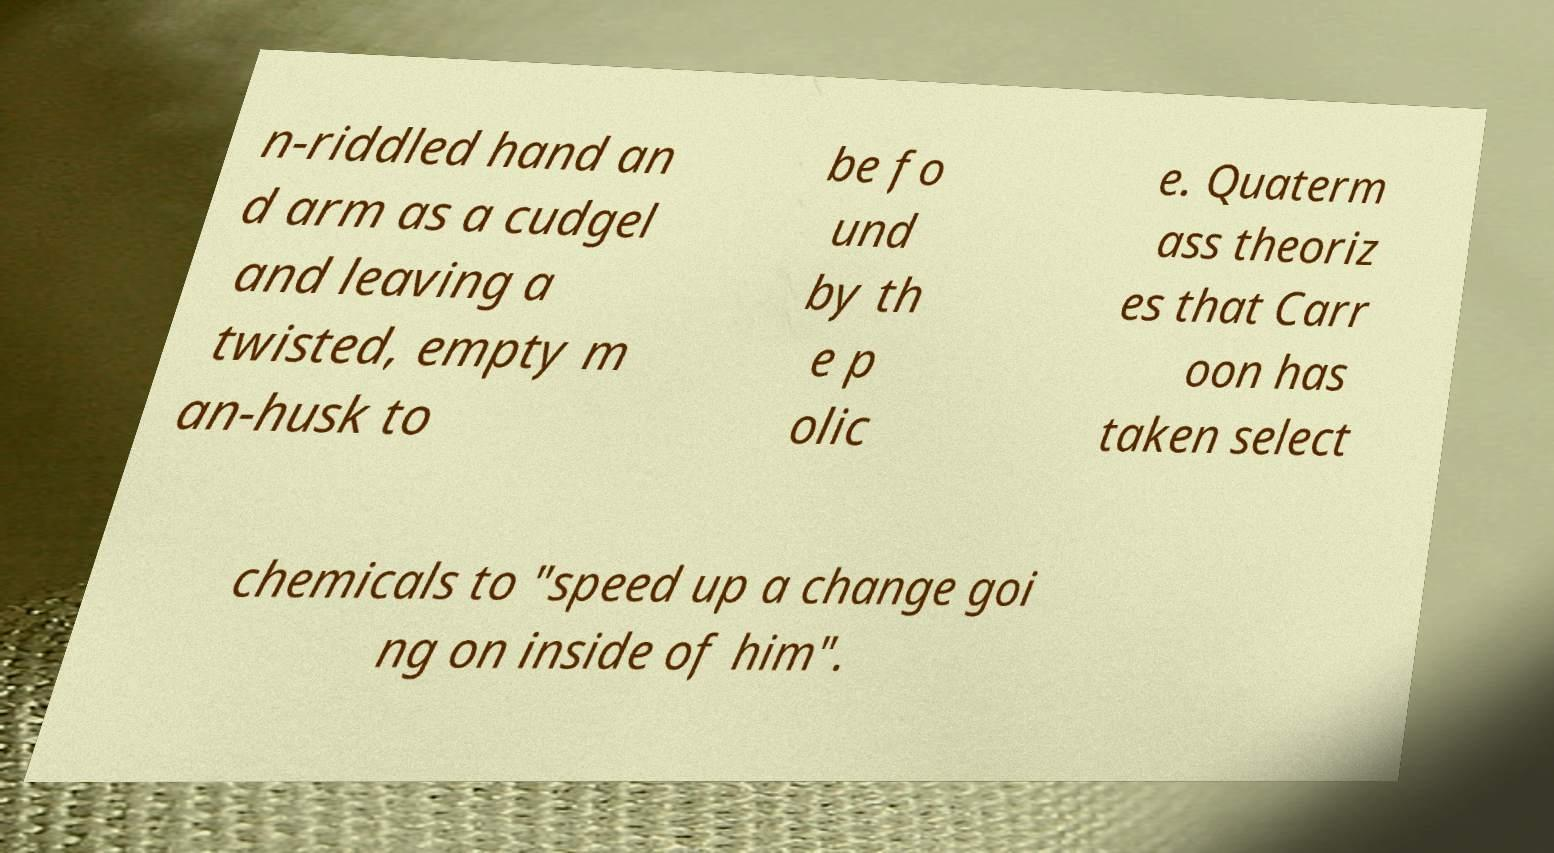Please identify and transcribe the text found in this image. n-riddled hand an d arm as a cudgel and leaving a twisted, empty m an-husk to be fo und by th e p olic e. Quaterm ass theoriz es that Carr oon has taken select chemicals to "speed up a change goi ng on inside of him". 